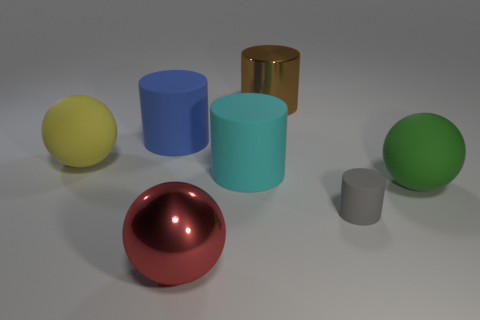Subtract all gray cylinders. How many cylinders are left? 3 Subtract all large matte balls. How many balls are left? 1 Add 1 big brown objects. How many objects exist? 8 Subtract all yellow cylinders. Subtract all red cubes. How many cylinders are left? 4 Subtract all cylinders. How many objects are left? 3 Subtract all large metallic cylinders. Subtract all small purple shiny things. How many objects are left? 6 Add 1 big blue objects. How many big blue objects are left? 2 Add 3 large blue cylinders. How many large blue cylinders exist? 4 Subtract 1 gray cylinders. How many objects are left? 6 